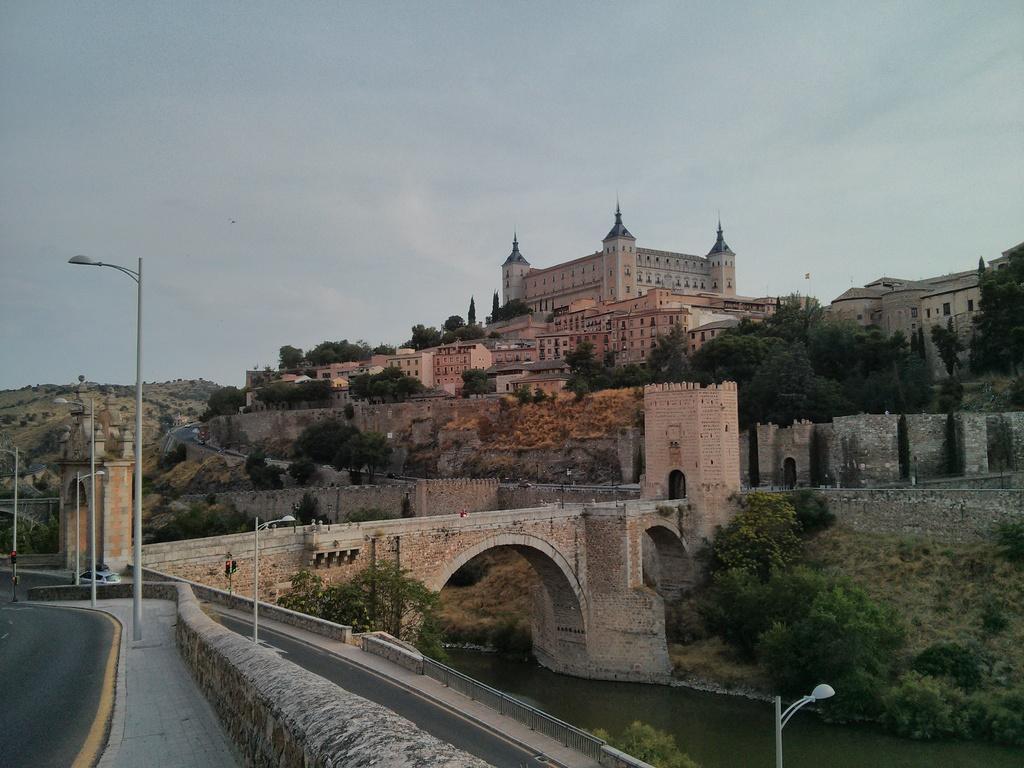In one or two sentences, can you explain what this image depicts? In this picture we can see buildings, trees, here we can see a bridge, electric poles with lights, vehicle, person and some objects, under this bridge we can see water and in the background we can see a mountain, sky. 